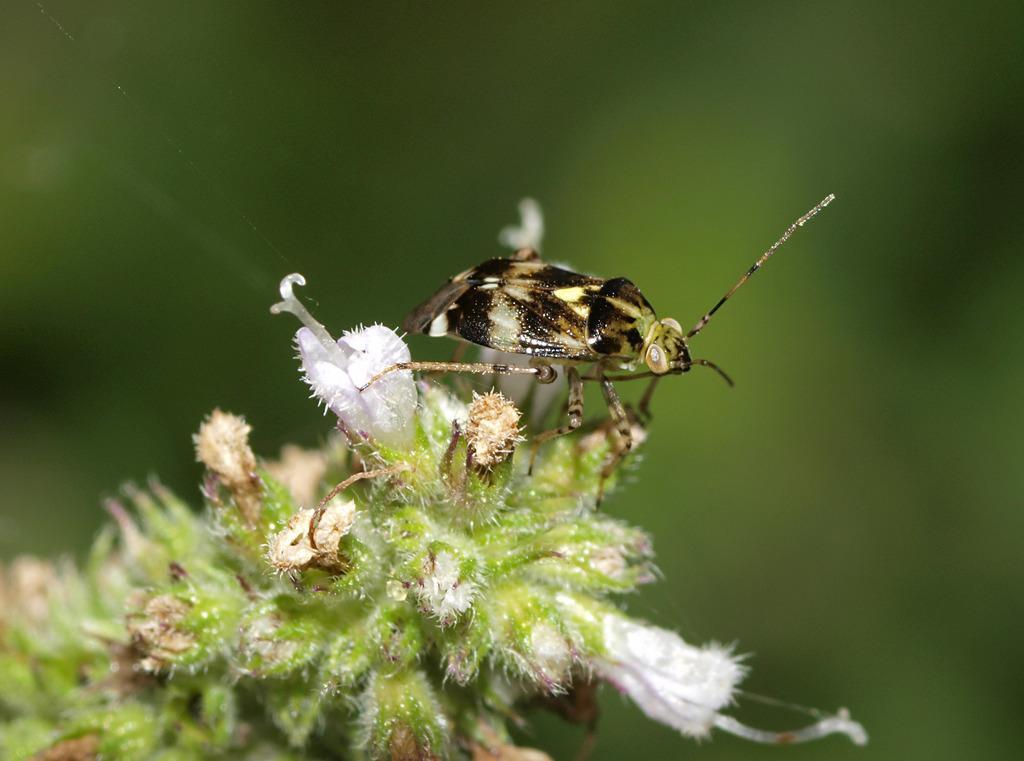Please provide a concise description of this image. In the foreground of this image, there is an insect on the flowers and we can also see the plant of it and the background image is blur. 